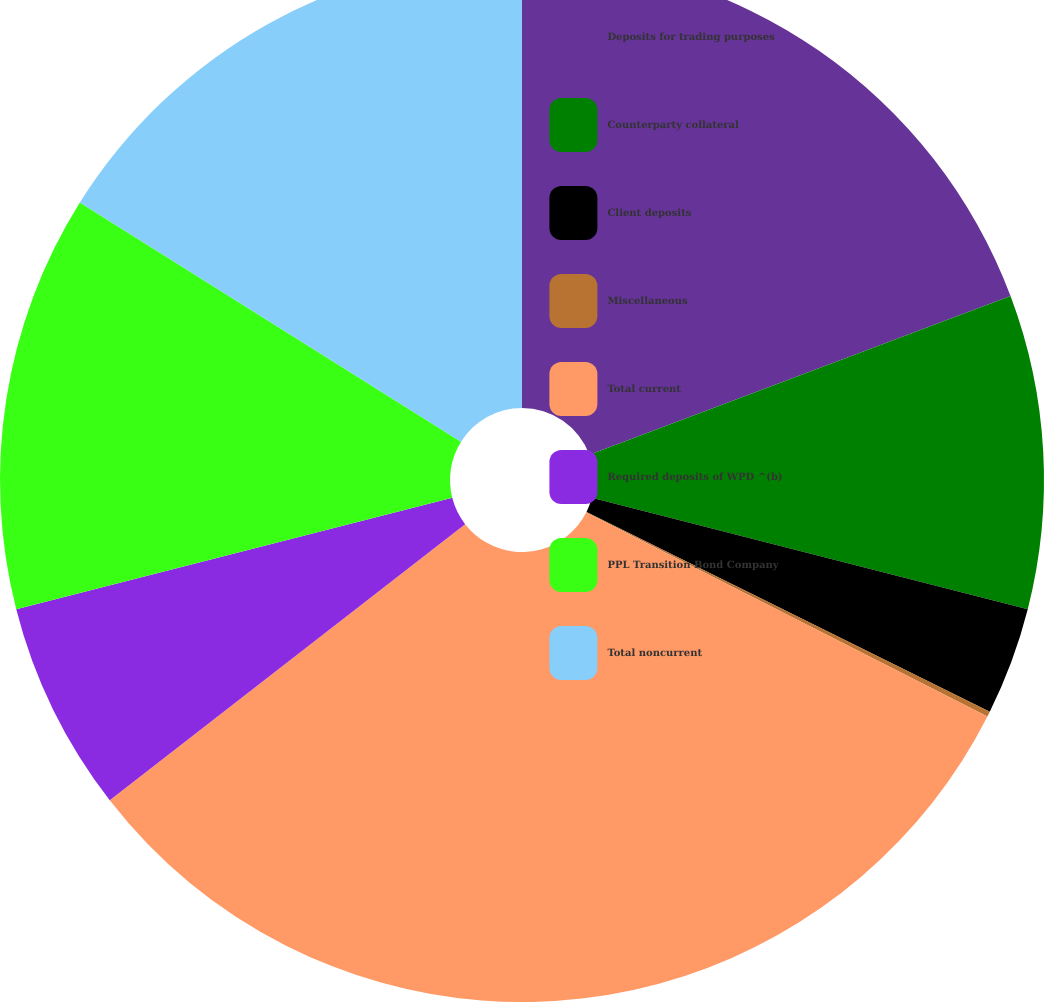Convert chart to OTSL. <chart><loc_0><loc_0><loc_500><loc_500><pie_chart><fcel>Deposits for trading purposes<fcel>Counterparty collateral<fcel>Client deposits<fcel>Miscellaneous<fcel>Total current<fcel>Required deposits of WPD ^(b)<fcel>PPL Transition Bond Company<fcel>Total noncurrent<nl><fcel>19.27%<fcel>9.71%<fcel>3.34%<fcel>0.16%<fcel>32.01%<fcel>6.53%<fcel>12.9%<fcel>16.08%<nl></chart> 